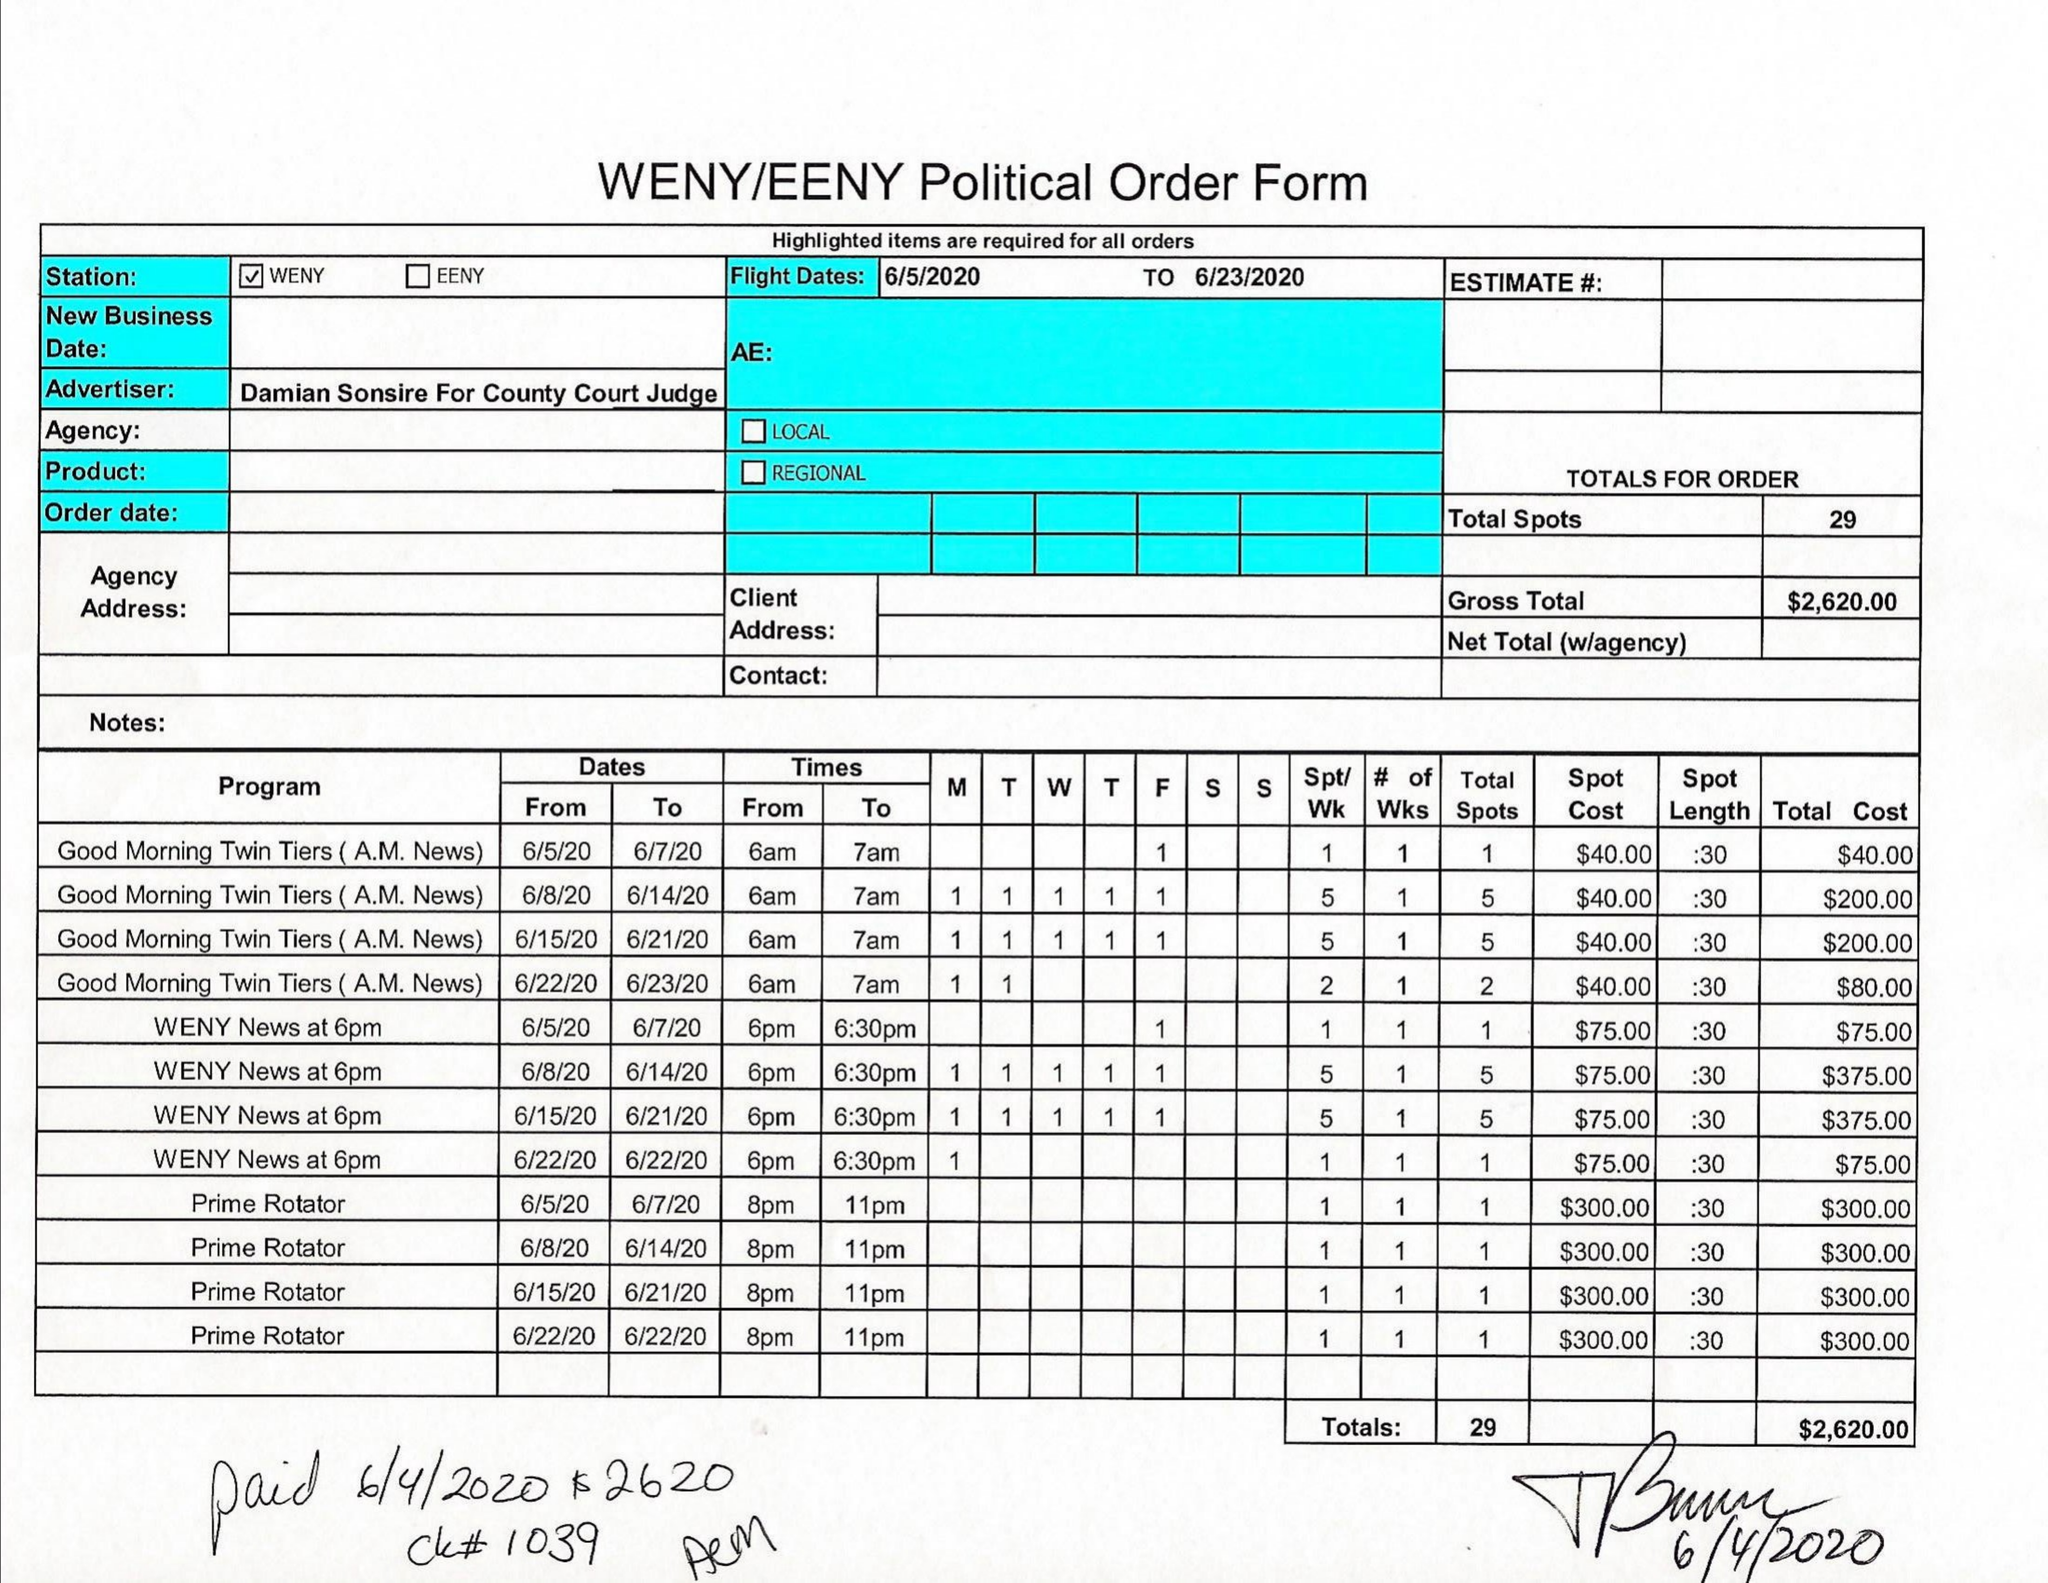What is the value for the flight_to?
Answer the question using a single word or phrase. 06/23/20 